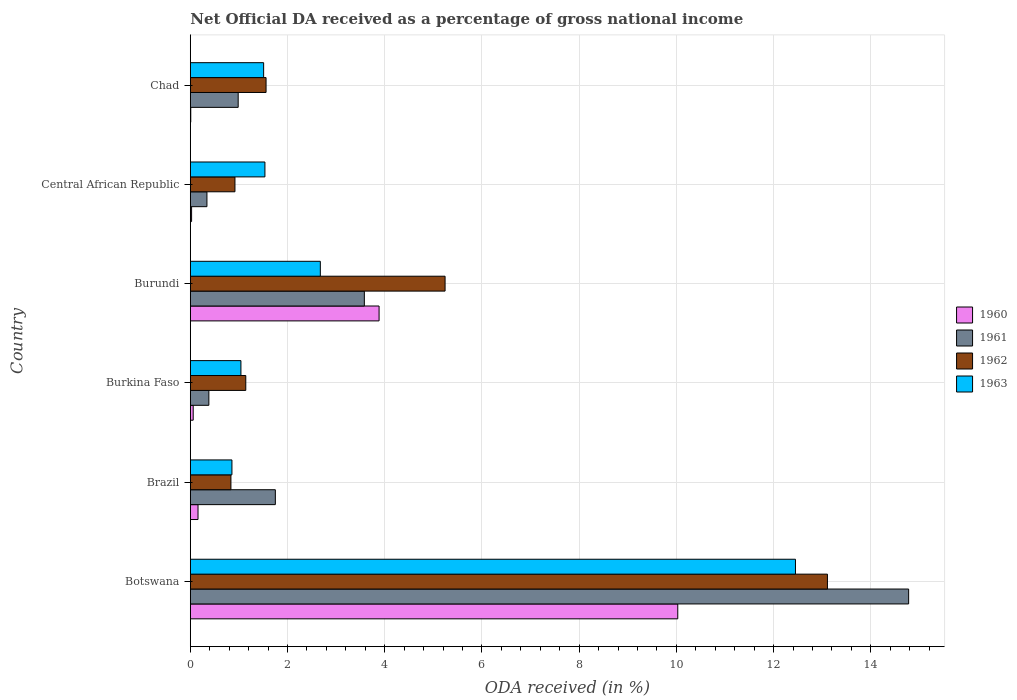How many different coloured bars are there?
Provide a succinct answer. 4. How many groups of bars are there?
Make the answer very short. 6. Are the number of bars per tick equal to the number of legend labels?
Keep it short and to the point. Yes. What is the label of the 6th group of bars from the top?
Your answer should be very brief. Botswana. What is the net official DA received in 1963 in Central African Republic?
Your answer should be very brief. 1.54. Across all countries, what is the maximum net official DA received in 1963?
Offer a terse response. 12.45. Across all countries, what is the minimum net official DA received in 1961?
Offer a very short reply. 0.34. In which country was the net official DA received in 1962 maximum?
Your response must be concise. Botswana. In which country was the net official DA received in 1962 minimum?
Provide a short and direct response. Brazil. What is the total net official DA received in 1962 in the graph?
Give a very brief answer. 22.8. What is the difference between the net official DA received in 1963 in Brazil and that in Chad?
Offer a very short reply. -0.65. What is the difference between the net official DA received in 1961 in Burundi and the net official DA received in 1963 in Burkina Faso?
Offer a very short reply. 2.54. What is the average net official DA received in 1960 per country?
Your response must be concise. 2.36. What is the difference between the net official DA received in 1960 and net official DA received in 1962 in Brazil?
Make the answer very short. -0.68. What is the ratio of the net official DA received in 1960 in Burkina Faso to that in Central African Republic?
Ensure brevity in your answer.  2.22. Is the net official DA received in 1963 in Burkina Faso less than that in Central African Republic?
Make the answer very short. Yes. Is the difference between the net official DA received in 1960 in Burkina Faso and Chad greater than the difference between the net official DA received in 1962 in Burkina Faso and Chad?
Provide a succinct answer. Yes. What is the difference between the highest and the second highest net official DA received in 1960?
Provide a succinct answer. 6.14. What is the difference between the highest and the lowest net official DA received in 1960?
Ensure brevity in your answer.  10.02. Is the sum of the net official DA received in 1960 in Brazil and Burkina Faso greater than the maximum net official DA received in 1961 across all countries?
Ensure brevity in your answer.  No. Is it the case that in every country, the sum of the net official DA received in 1960 and net official DA received in 1963 is greater than the sum of net official DA received in 1961 and net official DA received in 1962?
Offer a very short reply. No. Is it the case that in every country, the sum of the net official DA received in 1963 and net official DA received in 1962 is greater than the net official DA received in 1961?
Ensure brevity in your answer.  No. How many bars are there?
Your answer should be compact. 24. Are all the bars in the graph horizontal?
Your response must be concise. Yes. How many countries are there in the graph?
Make the answer very short. 6. What is the difference between two consecutive major ticks on the X-axis?
Ensure brevity in your answer.  2. Are the values on the major ticks of X-axis written in scientific E-notation?
Your response must be concise. No. Does the graph contain grids?
Ensure brevity in your answer.  Yes. What is the title of the graph?
Offer a terse response. Net Official DA received as a percentage of gross national income. What is the label or title of the X-axis?
Make the answer very short. ODA received (in %). What is the label or title of the Y-axis?
Your response must be concise. Country. What is the ODA received (in %) of 1960 in Botswana?
Keep it short and to the point. 10.03. What is the ODA received (in %) in 1961 in Botswana?
Your response must be concise. 14.78. What is the ODA received (in %) in 1962 in Botswana?
Make the answer very short. 13.11. What is the ODA received (in %) of 1963 in Botswana?
Ensure brevity in your answer.  12.45. What is the ODA received (in %) of 1960 in Brazil?
Your answer should be very brief. 0.16. What is the ODA received (in %) in 1961 in Brazil?
Offer a terse response. 1.75. What is the ODA received (in %) in 1962 in Brazil?
Make the answer very short. 0.84. What is the ODA received (in %) of 1963 in Brazil?
Offer a very short reply. 0.86. What is the ODA received (in %) in 1960 in Burkina Faso?
Ensure brevity in your answer.  0.06. What is the ODA received (in %) of 1961 in Burkina Faso?
Provide a short and direct response. 0.38. What is the ODA received (in %) of 1962 in Burkina Faso?
Offer a very short reply. 1.14. What is the ODA received (in %) in 1963 in Burkina Faso?
Keep it short and to the point. 1.04. What is the ODA received (in %) of 1960 in Burundi?
Your response must be concise. 3.88. What is the ODA received (in %) in 1961 in Burundi?
Ensure brevity in your answer.  3.58. What is the ODA received (in %) in 1962 in Burundi?
Make the answer very short. 5.24. What is the ODA received (in %) of 1963 in Burundi?
Keep it short and to the point. 2.68. What is the ODA received (in %) of 1960 in Central African Republic?
Your response must be concise. 0.03. What is the ODA received (in %) in 1961 in Central African Republic?
Provide a succinct answer. 0.34. What is the ODA received (in %) of 1962 in Central African Republic?
Your response must be concise. 0.92. What is the ODA received (in %) in 1963 in Central African Republic?
Your answer should be compact. 1.54. What is the ODA received (in %) in 1960 in Chad?
Your response must be concise. 0.01. What is the ODA received (in %) in 1961 in Chad?
Offer a terse response. 0.99. What is the ODA received (in %) in 1962 in Chad?
Your answer should be compact. 1.56. What is the ODA received (in %) in 1963 in Chad?
Provide a short and direct response. 1.51. Across all countries, what is the maximum ODA received (in %) of 1960?
Make the answer very short. 10.03. Across all countries, what is the maximum ODA received (in %) of 1961?
Make the answer very short. 14.78. Across all countries, what is the maximum ODA received (in %) of 1962?
Give a very brief answer. 13.11. Across all countries, what is the maximum ODA received (in %) in 1963?
Your answer should be very brief. 12.45. Across all countries, what is the minimum ODA received (in %) in 1960?
Keep it short and to the point. 0.01. Across all countries, what is the minimum ODA received (in %) in 1961?
Keep it short and to the point. 0.34. Across all countries, what is the minimum ODA received (in %) in 1962?
Give a very brief answer. 0.84. Across all countries, what is the minimum ODA received (in %) of 1963?
Your response must be concise. 0.86. What is the total ODA received (in %) in 1960 in the graph?
Provide a succinct answer. 14.17. What is the total ODA received (in %) of 1961 in the graph?
Provide a succinct answer. 21.82. What is the total ODA received (in %) of 1962 in the graph?
Offer a very short reply. 22.8. What is the total ODA received (in %) in 1963 in the graph?
Your response must be concise. 20.07. What is the difference between the ODA received (in %) of 1960 in Botswana and that in Brazil?
Your answer should be compact. 9.87. What is the difference between the ODA received (in %) of 1961 in Botswana and that in Brazil?
Ensure brevity in your answer.  13.03. What is the difference between the ODA received (in %) of 1962 in Botswana and that in Brazil?
Provide a succinct answer. 12.27. What is the difference between the ODA received (in %) of 1963 in Botswana and that in Brazil?
Make the answer very short. 11.59. What is the difference between the ODA received (in %) in 1960 in Botswana and that in Burkina Faso?
Provide a short and direct response. 9.97. What is the difference between the ODA received (in %) of 1961 in Botswana and that in Burkina Faso?
Give a very brief answer. 14.39. What is the difference between the ODA received (in %) of 1962 in Botswana and that in Burkina Faso?
Keep it short and to the point. 11.97. What is the difference between the ODA received (in %) in 1963 in Botswana and that in Burkina Faso?
Provide a succinct answer. 11.41. What is the difference between the ODA received (in %) of 1960 in Botswana and that in Burundi?
Give a very brief answer. 6.14. What is the difference between the ODA received (in %) of 1961 in Botswana and that in Burundi?
Your response must be concise. 11.2. What is the difference between the ODA received (in %) of 1962 in Botswana and that in Burundi?
Your answer should be compact. 7.87. What is the difference between the ODA received (in %) of 1963 in Botswana and that in Burundi?
Your answer should be compact. 9.77. What is the difference between the ODA received (in %) in 1960 in Botswana and that in Central African Republic?
Make the answer very short. 10. What is the difference between the ODA received (in %) of 1961 in Botswana and that in Central African Republic?
Provide a short and direct response. 14.43. What is the difference between the ODA received (in %) in 1962 in Botswana and that in Central African Republic?
Offer a terse response. 12.19. What is the difference between the ODA received (in %) in 1963 in Botswana and that in Central African Republic?
Give a very brief answer. 10.91. What is the difference between the ODA received (in %) of 1960 in Botswana and that in Chad?
Keep it short and to the point. 10.02. What is the difference between the ODA received (in %) of 1961 in Botswana and that in Chad?
Your answer should be compact. 13.79. What is the difference between the ODA received (in %) of 1962 in Botswana and that in Chad?
Offer a very short reply. 11.55. What is the difference between the ODA received (in %) in 1963 in Botswana and that in Chad?
Offer a very short reply. 10.94. What is the difference between the ODA received (in %) of 1960 in Brazil and that in Burkina Faso?
Provide a succinct answer. 0.1. What is the difference between the ODA received (in %) in 1961 in Brazil and that in Burkina Faso?
Your answer should be very brief. 1.37. What is the difference between the ODA received (in %) in 1962 in Brazil and that in Burkina Faso?
Provide a short and direct response. -0.31. What is the difference between the ODA received (in %) of 1963 in Brazil and that in Burkina Faso?
Offer a terse response. -0.18. What is the difference between the ODA received (in %) in 1960 in Brazil and that in Burundi?
Offer a terse response. -3.72. What is the difference between the ODA received (in %) in 1961 in Brazil and that in Burundi?
Your answer should be very brief. -1.83. What is the difference between the ODA received (in %) in 1962 in Brazil and that in Burundi?
Offer a very short reply. -4.41. What is the difference between the ODA received (in %) of 1963 in Brazil and that in Burundi?
Your answer should be very brief. -1.82. What is the difference between the ODA received (in %) of 1960 in Brazil and that in Central African Republic?
Your answer should be compact. 0.13. What is the difference between the ODA received (in %) in 1961 in Brazil and that in Central African Republic?
Provide a short and direct response. 1.41. What is the difference between the ODA received (in %) in 1962 in Brazil and that in Central African Republic?
Keep it short and to the point. -0.08. What is the difference between the ODA received (in %) in 1963 in Brazil and that in Central African Republic?
Provide a succinct answer. -0.68. What is the difference between the ODA received (in %) of 1960 in Brazil and that in Chad?
Offer a terse response. 0.15. What is the difference between the ODA received (in %) of 1961 in Brazil and that in Chad?
Provide a short and direct response. 0.76. What is the difference between the ODA received (in %) of 1962 in Brazil and that in Chad?
Provide a succinct answer. -0.72. What is the difference between the ODA received (in %) in 1963 in Brazil and that in Chad?
Ensure brevity in your answer.  -0.65. What is the difference between the ODA received (in %) of 1960 in Burkina Faso and that in Burundi?
Provide a short and direct response. -3.82. What is the difference between the ODA received (in %) in 1961 in Burkina Faso and that in Burundi?
Your answer should be very brief. -3.2. What is the difference between the ODA received (in %) of 1962 in Burkina Faso and that in Burundi?
Give a very brief answer. -4.1. What is the difference between the ODA received (in %) of 1963 in Burkina Faso and that in Burundi?
Give a very brief answer. -1.63. What is the difference between the ODA received (in %) in 1960 in Burkina Faso and that in Central African Republic?
Give a very brief answer. 0.03. What is the difference between the ODA received (in %) in 1961 in Burkina Faso and that in Central African Republic?
Keep it short and to the point. 0.04. What is the difference between the ODA received (in %) of 1962 in Burkina Faso and that in Central African Republic?
Make the answer very short. 0.22. What is the difference between the ODA received (in %) of 1963 in Burkina Faso and that in Central African Republic?
Give a very brief answer. -0.49. What is the difference between the ODA received (in %) of 1960 in Burkina Faso and that in Chad?
Give a very brief answer. 0.05. What is the difference between the ODA received (in %) in 1961 in Burkina Faso and that in Chad?
Your answer should be very brief. -0.6. What is the difference between the ODA received (in %) in 1962 in Burkina Faso and that in Chad?
Offer a terse response. -0.42. What is the difference between the ODA received (in %) of 1963 in Burkina Faso and that in Chad?
Provide a short and direct response. -0.47. What is the difference between the ODA received (in %) in 1960 in Burundi and that in Central African Republic?
Offer a very short reply. 3.86. What is the difference between the ODA received (in %) in 1961 in Burundi and that in Central African Republic?
Your response must be concise. 3.24. What is the difference between the ODA received (in %) of 1962 in Burundi and that in Central African Republic?
Provide a succinct answer. 4.32. What is the difference between the ODA received (in %) of 1963 in Burundi and that in Central African Republic?
Your answer should be very brief. 1.14. What is the difference between the ODA received (in %) of 1960 in Burundi and that in Chad?
Ensure brevity in your answer.  3.87. What is the difference between the ODA received (in %) of 1961 in Burundi and that in Chad?
Ensure brevity in your answer.  2.6. What is the difference between the ODA received (in %) in 1962 in Burundi and that in Chad?
Provide a short and direct response. 3.68. What is the difference between the ODA received (in %) in 1963 in Burundi and that in Chad?
Provide a succinct answer. 1.17. What is the difference between the ODA received (in %) in 1960 in Central African Republic and that in Chad?
Offer a very short reply. 0.02. What is the difference between the ODA received (in %) in 1961 in Central African Republic and that in Chad?
Offer a very short reply. -0.64. What is the difference between the ODA received (in %) in 1962 in Central African Republic and that in Chad?
Offer a terse response. -0.64. What is the difference between the ODA received (in %) in 1963 in Central African Republic and that in Chad?
Your answer should be compact. 0.03. What is the difference between the ODA received (in %) of 1960 in Botswana and the ODA received (in %) of 1961 in Brazil?
Provide a short and direct response. 8.28. What is the difference between the ODA received (in %) in 1960 in Botswana and the ODA received (in %) in 1962 in Brazil?
Offer a terse response. 9.19. What is the difference between the ODA received (in %) in 1960 in Botswana and the ODA received (in %) in 1963 in Brazil?
Provide a succinct answer. 9.17. What is the difference between the ODA received (in %) in 1961 in Botswana and the ODA received (in %) in 1962 in Brazil?
Give a very brief answer. 13.94. What is the difference between the ODA received (in %) in 1961 in Botswana and the ODA received (in %) in 1963 in Brazil?
Offer a very short reply. 13.92. What is the difference between the ODA received (in %) of 1962 in Botswana and the ODA received (in %) of 1963 in Brazil?
Provide a short and direct response. 12.25. What is the difference between the ODA received (in %) in 1960 in Botswana and the ODA received (in %) in 1961 in Burkina Faso?
Provide a succinct answer. 9.65. What is the difference between the ODA received (in %) in 1960 in Botswana and the ODA received (in %) in 1962 in Burkina Faso?
Offer a very short reply. 8.89. What is the difference between the ODA received (in %) of 1960 in Botswana and the ODA received (in %) of 1963 in Burkina Faso?
Your answer should be very brief. 8.99. What is the difference between the ODA received (in %) in 1961 in Botswana and the ODA received (in %) in 1962 in Burkina Faso?
Offer a terse response. 13.64. What is the difference between the ODA received (in %) of 1961 in Botswana and the ODA received (in %) of 1963 in Burkina Faso?
Your response must be concise. 13.74. What is the difference between the ODA received (in %) of 1962 in Botswana and the ODA received (in %) of 1963 in Burkina Faso?
Your answer should be compact. 12.07. What is the difference between the ODA received (in %) in 1960 in Botswana and the ODA received (in %) in 1961 in Burundi?
Your answer should be very brief. 6.45. What is the difference between the ODA received (in %) in 1960 in Botswana and the ODA received (in %) in 1962 in Burundi?
Your answer should be compact. 4.79. What is the difference between the ODA received (in %) of 1960 in Botswana and the ODA received (in %) of 1963 in Burundi?
Offer a very short reply. 7.35. What is the difference between the ODA received (in %) of 1961 in Botswana and the ODA received (in %) of 1962 in Burundi?
Ensure brevity in your answer.  9.54. What is the difference between the ODA received (in %) of 1961 in Botswana and the ODA received (in %) of 1963 in Burundi?
Make the answer very short. 12.1. What is the difference between the ODA received (in %) in 1962 in Botswana and the ODA received (in %) in 1963 in Burundi?
Give a very brief answer. 10.43. What is the difference between the ODA received (in %) of 1960 in Botswana and the ODA received (in %) of 1961 in Central African Republic?
Your response must be concise. 9.69. What is the difference between the ODA received (in %) in 1960 in Botswana and the ODA received (in %) in 1962 in Central African Republic?
Keep it short and to the point. 9.11. What is the difference between the ODA received (in %) of 1960 in Botswana and the ODA received (in %) of 1963 in Central African Republic?
Keep it short and to the point. 8.49. What is the difference between the ODA received (in %) in 1961 in Botswana and the ODA received (in %) in 1962 in Central African Republic?
Your answer should be very brief. 13.86. What is the difference between the ODA received (in %) of 1961 in Botswana and the ODA received (in %) of 1963 in Central African Republic?
Provide a short and direct response. 13.24. What is the difference between the ODA received (in %) of 1962 in Botswana and the ODA received (in %) of 1963 in Central African Republic?
Offer a very short reply. 11.57. What is the difference between the ODA received (in %) in 1960 in Botswana and the ODA received (in %) in 1961 in Chad?
Make the answer very short. 9.04. What is the difference between the ODA received (in %) of 1960 in Botswana and the ODA received (in %) of 1962 in Chad?
Offer a terse response. 8.47. What is the difference between the ODA received (in %) in 1960 in Botswana and the ODA received (in %) in 1963 in Chad?
Provide a short and direct response. 8.52. What is the difference between the ODA received (in %) of 1961 in Botswana and the ODA received (in %) of 1962 in Chad?
Your answer should be very brief. 13.22. What is the difference between the ODA received (in %) in 1961 in Botswana and the ODA received (in %) in 1963 in Chad?
Provide a short and direct response. 13.27. What is the difference between the ODA received (in %) of 1962 in Botswana and the ODA received (in %) of 1963 in Chad?
Your answer should be very brief. 11.6. What is the difference between the ODA received (in %) in 1960 in Brazil and the ODA received (in %) in 1961 in Burkina Faso?
Provide a short and direct response. -0.22. What is the difference between the ODA received (in %) in 1960 in Brazil and the ODA received (in %) in 1962 in Burkina Faso?
Provide a short and direct response. -0.98. What is the difference between the ODA received (in %) in 1960 in Brazil and the ODA received (in %) in 1963 in Burkina Faso?
Make the answer very short. -0.88. What is the difference between the ODA received (in %) of 1961 in Brazil and the ODA received (in %) of 1962 in Burkina Faso?
Keep it short and to the point. 0.61. What is the difference between the ODA received (in %) in 1961 in Brazil and the ODA received (in %) in 1963 in Burkina Faso?
Your answer should be very brief. 0.71. What is the difference between the ODA received (in %) in 1962 in Brazil and the ODA received (in %) in 1963 in Burkina Faso?
Your response must be concise. -0.21. What is the difference between the ODA received (in %) of 1960 in Brazil and the ODA received (in %) of 1961 in Burundi?
Offer a terse response. -3.42. What is the difference between the ODA received (in %) of 1960 in Brazil and the ODA received (in %) of 1962 in Burundi?
Your response must be concise. -5.08. What is the difference between the ODA received (in %) of 1960 in Brazil and the ODA received (in %) of 1963 in Burundi?
Keep it short and to the point. -2.52. What is the difference between the ODA received (in %) in 1961 in Brazil and the ODA received (in %) in 1962 in Burundi?
Provide a succinct answer. -3.49. What is the difference between the ODA received (in %) of 1961 in Brazil and the ODA received (in %) of 1963 in Burundi?
Make the answer very short. -0.93. What is the difference between the ODA received (in %) in 1962 in Brazil and the ODA received (in %) in 1963 in Burundi?
Ensure brevity in your answer.  -1.84. What is the difference between the ODA received (in %) of 1960 in Brazil and the ODA received (in %) of 1961 in Central African Republic?
Give a very brief answer. -0.18. What is the difference between the ODA received (in %) of 1960 in Brazil and the ODA received (in %) of 1962 in Central African Republic?
Your response must be concise. -0.76. What is the difference between the ODA received (in %) in 1960 in Brazil and the ODA received (in %) in 1963 in Central African Republic?
Give a very brief answer. -1.38. What is the difference between the ODA received (in %) of 1961 in Brazil and the ODA received (in %) of 1962 in Central African Republic?
Your response must be concise. 0.83. What is the difference between the ODA received (in %) of 1961 in Brazil and the ODA received (in %) of 1963 in Central African Republic?
Your answer should be compact. 0.21. What is the difference between the ODA received (in %) of 1962 in Brazil and the ODA received (in %) of 1963 in Central African Republic?
Your answer should be compact. -0.7. What is the difference between the ODA received (in %) of 1960 in Brazil and the ODA received (in %) of 1961 in Chad?
Give a very brief answer. -0.83. What is the difference between the ODA received (in %) in 1960 in Brazil and the ODA received (in %) in 1962 in Chad?
Your answer should be compact. -1.4. What is the difference between the ODA received (in %) of 1960 in Brazil and the ODA received (in %) of 1963 in Chad?
Offer a terse response. -1.35. What is the difference between the ODA received (in %) in 1961 in Brazil and the ODA received (in %) in 1962 in Chad?
Offer a terse response. 0.19. What is the difference between the ODA received (in %) of 1961 in Brazil and the ODA received (in %) of 1963 in Chad?
Provide a short and direct response. 0.24. What is the difference between the ODA received (in %) in 1962 in Brazil and the ODA received (in %) in 1963 in Chad?
Make the answer very short. -0.67. What is the difference between the ODA received (in %) of 1960 in Burkina Faso and the ODA received (in %) of 1961 in Burundi?
Give a very brief answer. -3.52. What is the difference between the ODA received (in %) of 1960 in Burkina Faso and the ODA received (in %) of 1962 in Burundi?
Your response must be concise. -5.18. What is the difference between the ODA received (in %) of 1960 in Burkina Faso and the ODA received (in %) of 1963 in Burundi?
Your answer should be compact. -2.62. What is the difference between the ODA received (in %) in 1961 in Burkina Faso and the ODA received (in %) in 1962 in Burundi?
Give a very brief answer. -4.86. What is the difference between the ODA received (in %) of 1961 in Burkina Faso and the ODA received (in %) of 1963 in Burundi?
Make the answer very short. -2.29. What is the difference between the ODA received (in %) in 1962 in Burkina Faso and the ODA received (in %) in 1963 in Burundi?
Your answer should be compact. -1.53. What is the difference between the ODA received (in %) of 1960 in Burkina Faso and the ODA received (in %) of 1961 in Central African Republic?
Offer a very short reply. -0.28. What is the difference between the ODA received (in %) of 1960 in Burkina Faso and the ODA received (in %) of 1962 in Central African Republic?
Give a very brief answer. -0.86. What is the difference between the ODA received (in %) in 1960 in Burkina Faso and the ODA received (in %) in 1963 in Central African Republic?
Your answer should be compact. -1.48. What is the difference between the ODA received (in %) in 1961 in Burkina Faso and the ODA received (in %) in 1962 in Central African Republic?
Give a very brief answer. -0.54. What is the difference between the ODA received (in %) of 1961 in Burkina Faso and the ODA received (in %) of 1963 in Central African Republic?
Your response must be concise. -1.15. What is the difference between the ODA received (in %) of 1962 in Burkina Faso and the ODA received (in %) of 1963 in Central African Republic?
Make the answer very short. -0.39. What is the difference between the ODA received (in %) in 1960 in Burkina Faso and the ODA received (in %) in 1961 in Chad?
Make the answer very short. -0.93. What is the difference between the ODA received (in %) of 1960 in Burkina Faso and the ODA received (in %) of 1962 in Chad?
Provide a short and direct response. -1.5. What is the difference between the ODA received (in %) in 1960 in Burkina Faso and the ODA received (in %) in 1963 in Chad?
Your answer should be very brief. -1.45. What is the difference between the ODA received (in %) of 1961 in Burkina Faso and the ODA received (in %) of 1962 in Chad?
Provide a succinct answer. -1.18. What is the difference between the ODA received (in %) in 1961 in Burkina Faso and the ODA received (in %) in 1963 in Chad?
Provide a short and direct response. -1.13. What is the difference between the ODA received (in %) in 1962 in Burkina Faso and the ODA received (in %) in 1963 in Chad?
Your response must be concise. -0.37. What is the difference between the ODA received (in %) in 1960 in Burundi and the ODA received (in %) in 1961 in Central African Republic?
Provide a short and direct response. 3.54. What is the difference between the ODA received (in %) of 1960 in Burundi and the ODA received (in %) of 1962 in Central African Republic?
Provide a succinct answer. 2.96. What is the difference between the ODA received (in %) of 1960 in Burundi and the ODA received (in %) of 1963 in Central African Republic?
Keep it short and to the point. 2.35. What is the difference between the ODA received (in %) of 1961 in Burundi and the ODA received (in %) of 1962 in Central African Republic?
Provide a short and direct response. 2.66. What is the difference between the ODA received (in %) of 1961 in Burundi and the ODA received (in %) of 1963 in Central African Republic?
Your answer should be compact. 2.05. What is the difference between the ODA received (in %) of 1962 in Burundi and the ODA received (in %) of 1963 in Central African Republic?
Make the answer very short. 3.71. What is the difference between the ODA received (in %) in 1960 in Burundi and the ODA received (in %) in 1961 in Chad?
Your response must be concise. 2.9. What is the difference between the ODA received (in %) in 1960 in Burundi and the ODA received (in %) in 1962 in Chad?
Make the answer very short. 2.33. What is the difference between the ODA received (in %) of 1960 in Burundi and the ODA received (in %) of 1963 in Chad?
Your answer should be compact. 2.37. What is the difference between the ODA received (in %) in 1961 in Burundi and the ODA received (in %) in 1962 in Chad?
Your answer should be compact. 2.02. What is the difference between the ODA received (in %) of 1961 in Burundi and the ODA received (in %) of 1963 in Chad?
Provide a succinct answer. 2.07. What is the difference between the ODA received (in %) in 1962 in Burundi and the ODA received (in %) in 1963 in Chad?
Your response must be concise. 3.73. What is the difference between the ODA received (in %) of 1960 in Central African Republic and the ODA received (in %) of 1961 in Chad?
Your response must be concise. -0.96. What is the difference between the ODA received (in %) of 1960 in Central African Republic and the ODA received (in %) of 1962 in Chad?
Ensure brevity in your answer.  -1.53. What is the difference between the ODA received (in %) in 1960 in Central African Republic and the ODA received (in %) in 1963 in Chad?
Provide a succinct answer. -1.48. What is the difference between the ODA received (in %) of 1961 in Central African Republic and the ODA received (in %) of 1962 in Chad?
Keep it short and to the point. -1.22. What is the difference between the ODA received (in %) of 1961 in Central African Republic and the ODA received (in %) of 1963 in Chad?
Your answer should be very brief. -1.17. What is the difference between the ODA received (in %) in 1962 in Central African Republic and the ODA received (in %) in 1963 in Chad?
Keep it short and to the point. -0.59. What is the average ODA received (in %) in 1960 per country?
Give a very brief answer. 2.36. What is the average ODA received (in %) of 1961 per country?
Make the answer very short. 3.64. What is the average ODA received (in %) in 1962 per country?
Offer a terse response. 3.8. What is the average ODA received (in %) of 1963 per country?
Provide a short and direct response. 3.34. What is the difference between the ODA received (in %) of 1960 and ODA received (in %) of 1961 in Botswana?
Provide a succinct answer. -4.75. What is the difference between the ODA received (in %) in 1960 and ODA received (in %) in 1962 in Botswana?
Make the answer very short. -3.08. What is the difference between the ODA received (in %) of 1960 and ODA received (in %) of 1963 in Botswana?
Your answer should be compact. -2.42. What is the difference between the ODA received (in %) in 1961 and ODA received (in %) in 1962 in Botswana?
Offer a terse response. 1.67. What is the difference between the ODA received (in %) of 1961 and ODA received (in %) of 1963 in Botswana?
Keep it short and to the point. 2.33. What is the difference between the ODA received (in %) in 1962 and ODA received (in %) in 1963 in Botswana?
Give a very brief answer. 0.66. What is the difference between the ODA received (in %) of 1960 and ODA received (in %) of 1961 in Brazil?
Ensure brevity in your answer.  -1.59. What is the difference between the ODA received (in %) in 1960 and ODA received (in %) in 1962 in Brazil?
Your answer should be very brief. -0.68. What is the difference between the ODA received (in %) of 1960 and ODA received (in %) of 1963 in Brazil?
Provide a short and direct response. -0.7. What is the difference between the ODA received (in %) of 1961 and ODA received (in %) of 1962 in Brazil?
Provide a succinct answer. 0.91. What is the difference between the ODA received (in %) of 1961 and ODA received (in %) of 1963 in Brazil?
Make the answer very short. 0.89. What is the difference between the ODA received (in %) of 1962 and ODA received (in %) of 1963 in Brazil?
Give a very brief answer. -0.02. What is the difference between the ODA received (in %) in 1960 and ODA received (in %) in 1961 in Burkina Faso?
Keep it short and to the point. -0.32. What is the difference between the ODA received (in %) of 1960 and ODA received (in %) of 1962 in Burkina Faso?
Provide a succinct answer. -1.08. What is the difference between the ODA received (in %) of 1960 and ODA received (in %) of 1963 in Burkina Faso?
Give a very brief answer. -0.98. What is the difference between the ODA received (in %) of 1961 and ODA received (in %) of 1962 in Burkina Faso?
Offer a very short reply. -0.76. What is the difference between the ODA received (in %) of 1961 and ODA received (in %) of 1963 in Burkina Faso?
Your response must be concise. -0.66. What is the difference between the ODA received (in %) of 1962 and ODA received (in %) of 1963 in Burkina Faso?
Offer a terse response. 0.1. What is the difference between the ODA received (in %) of 1960 and ODA received (in %) of 1961 in Burundi?
Make the answer very short. 0.3. What is the difference between the ODA received (in %) in 1960 and ODA received (in %) in 1962 in Burundi?
Offer a very short reply. -1.36. What is the difference between the ODA received (in %) of 1960 and ODA received (in %) of 1963 in Burundi?
Your response must be concise. 1.21. What is the difference between the ODA received (in %) in 1961 and ODA received (in %) in 1962 in Burundi?
Provide a short and direct response. -1.66. What is the difference between the ODA received (in %) of 1961 and ODA received (in %) of 1963 in Burundi?
Your answer should be compact. 0.91. What is the difference between the ODA received (in %) of 1962 and ODA received (in %) of 1963 in Burundi?
Provide a short and direct response. 2.57. What is the difference between the ODA received (in %) in 1960 and ODA received (in %) in 1961 in Central African Republic?
Offer a very short reply. -0.32. What is the difference between the ODA received (in %) in 1960 and ODA received (in %) in 1962 in Central African Republic?
Provide a short and direct response. -0.89. What is the difference between the ODA received (in %) in 1960 and ODA received (in %) in 1963 in Central African Republic?
Make the answer very short. -1.51. What is the difference between the ODA received (in %) of 1961 and ODA received (in %) of 1962 in Central African Republic?
Offer a terse response. -0.58. What is the difference between the ODA received (in %) of 1961 and ODA received (in %) of 1963 in Central African Republic?
Offer a terse response. -1.19. What is the difference between the ODA received (in %) of 1962 and ODA received (in %) of 1963 in Central African Republic?
Offer a terse response. -0.62. What is the difference between the ODA received (in %) in 1960 and ODA received (in %) in 1961 in Chad?
Make the answer very short. -0.98. What is the difference between the ODA received (in %) in 1960 and ODA received (in %) in 1962 in Chad?
Ensure brevity in your answer.  -1.55. What is the difference between the ODA received (in %) in 1960 and ODA received (in %) in 1963 in Chad?
Make the answer very short. -1.5. What is the difference between the ODA received (in %) of 1961 and ODA received (in %) of 1962 in Chad?
Offer a very short reply. -0.57. What is the difference between the ODA received (in %) in 1961 and ODA received (in %) in 1963 in Chad?
Make the answer very short. -0.52. What is the difference between the ODA received (in %) of 1962 and ODA received (in %) of 1963 in Chad?
Keep it short and to the point. 0.05. What is the ratio of the ODA received (in %) in 1960 in Botswana to that in Brazil?
Provide a short and direct response. 63.08. What is the ratio of the ODA received (in %) in 1961 in Botswana to that in Brazil?
Keep it short and to the point. 8.45. What is the ratio of the ODA received (in %) in 1962 in Botswana to that in Brazil?
Your answer should be compact. 15.68. What is the ratio of the ODA received (in %) of 1963 in Botswana to that in Brazil?
Give a very brief answer. 14.53. What is the ratio of the ODA received (in %) in 1960 in Botswana to that in Burkina Faso?
Your answer should be very brief. 167.91. What is the ratio of the ODA received (in %) in 1961 in Botswana to that in Burkina Faso?
Ensure brevity in your answer.  38.69. What is the ratio of the ODA received (in %) of 1962 in Botswana to that in Burkina Faso?
Offer a terse response. 11.48. What is the ratio of the ODA received (in %) in 1963 in Botswana to that in Burkina Faso?
Offer a very short reply. 11.95. What is the ratio of the ODA received (in %) of 1960 in Botswana to that in Burundi?
Give a very brief answer. 2.58. What is the ratio of the ODA received (in %) of 1961 in Botswana to that in Burundi?
Your answer should be compact. 4.13. What is the ratio of the ODA received (in %) in 1962 in Botswana to that in Burundi?
Provide a succinct answer. 2.5. What is the ratio of the ODA received (in %) in 1963 in Botswana to that in Burundi?
Provide a succinct answer. 4.65. What is the ratio of the ODA received (in %) in 1960 in Botswana to that in Central African Republic?
Your answer should be very brief. 373.52. What is the ratio of the ODA received (in %) in 1961 in Botswana to that in Central African Republic?
Your answer should be very brief. 43.18. What is the ratio of the ODA received (in %) in 1962 in Botswana to that in Central African Republic?
Provide a succinct answer. 14.27. What is the ratio of the ODA received (in %) in 1963 in Botswana to that in Central African Republic?
Provide a succinct answer. 8.11. What is the ratio of the ODA received (in %) of 1960 in Botswana to that in Chad?
Your answer should be compact. 1041.08. What is the ratio of the ODA received (in %) of 1961 in Botswana to that in Chad?
Offer a very short reply. 15. What is the ratio of the ODA received (in %) of 1962 in Botswana to that in Chad?
Offer a very short reply. 8.41. What is the ratio of the ODA received (in %) of 1963 in Botswana to that in Chad?
Make the answer very short. 8.25. What is the ratio of the ODA received (in %) in 1960 in Brazil to that in Burkina Faso?
Your response must be concise. 2.66. What is the ratio of the ODA received (in %) of 1961 in Brazil to that in Burkina Faso?
Ensure brevity in your answer.  4.58. What is the ratio of the ODA received (in %) in 1962 in Brazil to that in Burkina Faso?
Make the answer very short. 0.73. What is the ratio of the ODA received (in %) in 1963 in Brazil to that in Burkina Faso?
Offer a very short reply. 0.82. What is the ratio of the ODA received (in %) of 1960 in Brazil to that in Burundi?
Keep it short and to the point. 0.04. What is the ratio of the ODA received (in %) of 1961 in Brazil to that in Burundi?
Provide a short and direct response. 0.49. What is the ratio of the ODA received (in %) of 1962 in Brazil to that in Burundi?
Ensure brevity in your answer.  0.16. What is the ratio of the ODA received (in %) in 1963 in Brazil to that in Burundi?
Provide a short and direct response. 0.32. What is the ratio of the ODA received (in %) in 1960 in Brazil to that in Central African Republic?
Offer a very short reply. 5.92. What is the ratio of the ODA received (in %) of 1961 in Brazil to that in Central African Republic?
Offer a terse response. 5.11. What is the ratio of the ODA received (in %) of 1962 in Brazil to that in Central African Republic?
Provide a short and direct response. 0.91. What is the ratio of the ODA received (in %) in 1963 in Brazil to that in Central African Republic?
Your response must be concise. 0.56. What is the ratio of the ODA received (in %) in 1960 in Brazil to that in Chad?
Make the answer very short. 16.51. What is the ratio of the ODA received (in %) of 1961 in Brazil to that in Chad?
Offer a terse response. 1.78. What is the ratio of the ODA received (in %) of 1962 in Brazil to that in Chad?
Provide a short and direct response. 0.54. What is the ratio of the ODA received (in %) of 1963 in Brazil to that in Chad?
Provide a succinct answer. 0.57. What is the ratio of the ODA received (in %) of 1960 in Burkina Faso to that in Burundi?
Provide a succinct answer. 0.02. What is the ratio of the ODA received (in %) in 1961 in Burkina Faso to that in Burundi?
Make the answer very short. 0.11. What is the ratio of the ODA received (in %) in 1962 in Burkina Faso to that in Burundi?
Provide a succinct answer. 0.22. What is the ratio of the ODA received (in %) in 1963 in Burkina Faso to that in Burundi?
Your answer should be compact. 0.39. What is the ratio of the ODA received (in %) of 1960 in Burkina Faso to that in Central African Republic?
Your answer should be very brief. 2.22. What is the ratio of the ODA received (in %) in 1961 in Burkina Faso to that in Central African Republic?
Your answer should be compact. 1.12. What is the ratio of the ODA received (in %) of 1962 in Burkina Faso to that in Central African Republic?
Your answer should be compact. 1.24. What is the ratio of the ODA received (in %) of 1963 in Burkina Faso to that in Central African Republic?
Give a very brief answer. 0.68. What is the ratio of the ODA received (in %) in 1960 in Burkina Faso to that in Chad?
Provide a short and direct response. 6.2. What is the ratio of the ODA received (in %) in 1961 in Burkina Faso to that in Chad?
Give a very brief answer. 0.39. What is the ratio of the ODA received (in %) of 1962 in Burkina Faso to that in Chad?
Provide a succinct answer. 0.73. What is the ratio of the ODA received (in %) of 1963 in Burkina Faso to that in Chad?
Ensure brevity in your answer.  0.69. What is the ratio of the ODA received (in %) in 1960 in Burundi to that in Central African Republic?
Provide a succinct answer. 144.66. What is the ratio of the ODA received (in %) in 1961 in Burundi to that in Central African Republic?
Offer a very short reply. 10.46. What is the ratio of the ODA received (in %) of 1962 in Burundi to that in Central African Republic?
Your answer should be very brief. 5.7. What is the ratio of the ODA received (in %) of 1963 in Burundi to that in Central African Republic?
Your response must be concise. 1.74. What is the ratio of the ODA received (in %) of 1960 in Burundi to that in Chad?
Provide a succinct answer. 403.2. What is the ratio of the ODA received (in %) of 1961 in Burundi to that in Chad?
Offer a very short reply. 3.63. What is the ratio of the ODA received (in %) in 1962 in Burundi to that in Chad?
Offer a very short reply. 3.36. What is the ratio of the ODA received (in %) of 1963 in Burundi to that in Chad?
Provide a succinct answer. 1.77. What is the ratio of the ODA received (in %) of 1960 in Central African Republic to that in Chad?
Keep it short and to the point. 2.79. What is the ratio of the ODA received (in %) in 1961 in Central African Republic to that in Chad?
Ensure brevity in your answer.  0.35. What is the ratio of the ODA received (in %) of 1962 in Central African Republic to that in Chad?
Your answer should be very brief. 0.59. What is the ratio of the ODA received (in %) in 1963 in Central African Republic to that in Chad?
Make the answer very short. 1.02. What is the difference between the highest and the second highest ODA received (in %) of 1960?
Your answer should be very brief. 6.14. What is the difference between the highest and the second highest ODA received (in %) in 1961?
Make the answer very short. 11.2. What is the difference between the highest and the second highest ODA received (in %) of 1962?
Make the answer very short. 7.87. What is the difference between the highest and the second highest ODA received (in %) in 1963?
Provide a succinct answer. 9.77. What is the difference between the highest and the lowest ODA received (in %) in 1960?
Your response must be concise. 10.02. What is the difference between the highest and the lowest ODA received (in %) in 1961?
Your response must be concise. 14.43. What is the difference between the highest and the lowest ODA received (in %) in 1962?
Keep it short and to the point. 12.27. What is the difference between the highest and the lowest ODA received (in %) in 1963?
Keep it short and to the point. 11.59. 